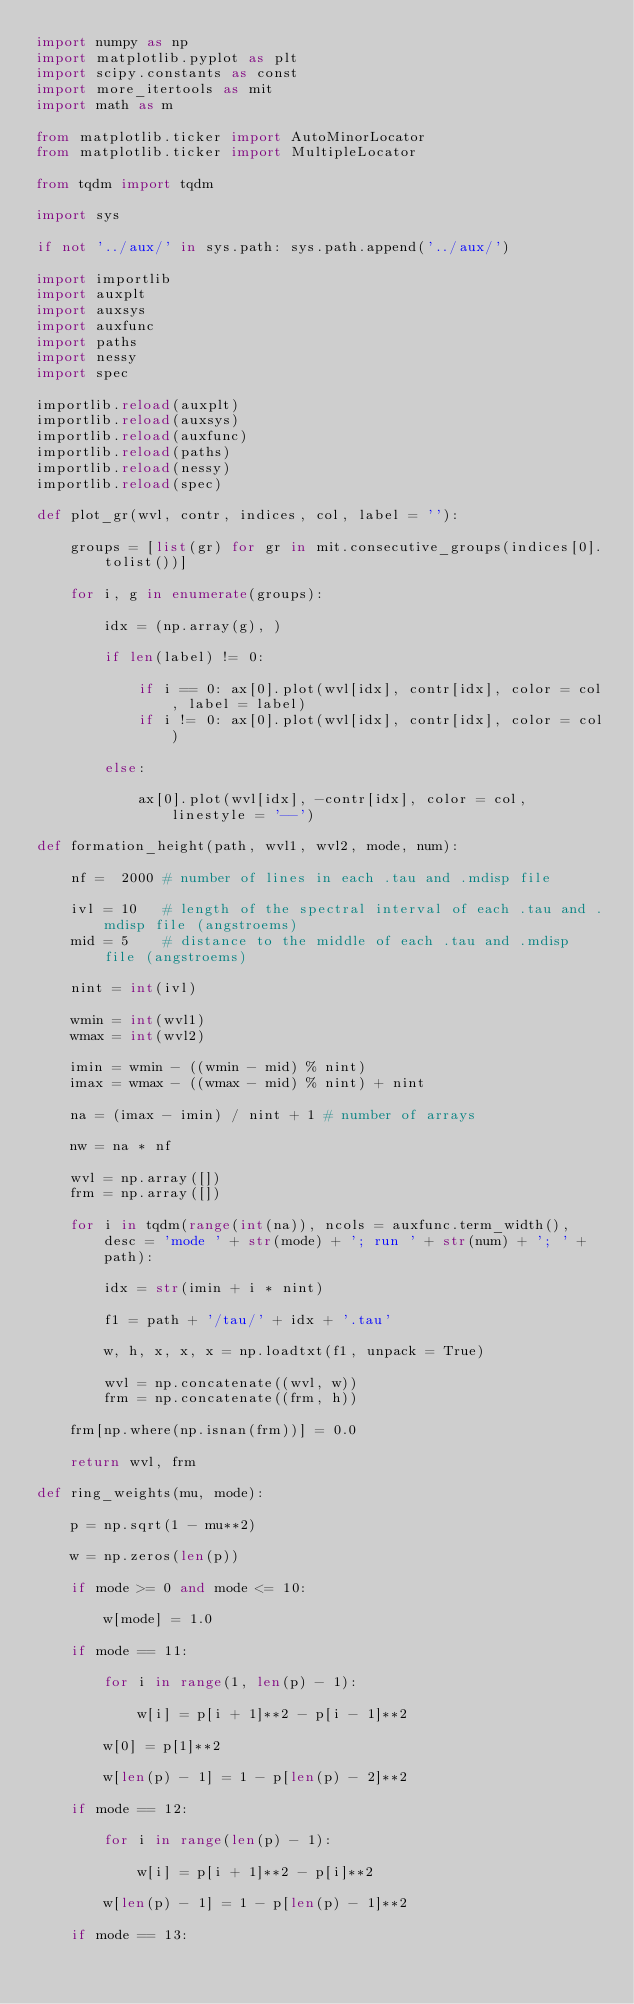Convert code to text. <code><loc_0><loc_0><loc_500><loc_500><_Python_>import numpy as np
import matplotlib.pyplot as plt
import scipy.constants as const
import more_itertools as mit
import math as m

from matplotlib.ticker import AutoMinorLocator
from matplotlib.ticker import MultipleLocator

from tqdm import tqdm

import sys

if not '../aux/' in sys.path: sys.path.append('../aux/')

import importlib
import auxplt
import auxsys
import auxfunc
import paths
import nessy
import spec

importlib.reload(auxplt)
importlib.reload(auxsys)
importlib.reload(auxfunc)
importlib.reload(paths)
importlib.reload(nessy)
importlib.reload(spec)

def plot_gr(wvl, contr, indices, col, label = ''):

    groups = [list(gr) for gr in mit.consecutive_groups(indices[0].tolist())]
    
    for i, g in enumerate(groups):

        idx = (np.array(g), )

        if len(label) != 0:

            if i == 0: ax[0].plot(wvl[idx], contr[idx], color = col, label = label)
            if i != 0: ax[0].plot(wvl[idx], contr[idx], color = col)

        else:

            ax[0].plot(wvl[idx], -contr[idx], color = col, linestyle = '--')

def formation_height(path, wvl1, wvl2, mode, num):

    nf =  2000 # number of lines in each .tau and .mdisp file

    ivl = 10   # length of the spectral interval of each .tau and .mdisp file (angstroems)
    mid = 5    # distance to the middle of each .tau and .mdisp file (angstroems)

    nint = int(ivl)

    wmin = int(wvl1)
    wmax = int(wvl2)

    imin = wmin - ((wmin - mid) % nint)
    imax = wmax - ((wmax - mid) % nint) + nint

    na = (imax - imin) / nint + 1 # number of arrays

    nw = na * nf

    wvl = np.array([])
    frm = np.array([])

    for i in tqdm(range(int(na)), ncols = auxfunc.term_width(), desc = 'mode ' + str(mode) + '; run ' + str(num) + '; ' + path):

        idx = str(imin + i * nint)

        f1 = path + '/tau/' + idx + '.tau'

        w, h, x, x, x = np.loadtxt(f1, unpack = True)

        wvl = np.concatenate((wvl, w))
        frm = np.concatenate((frm, h))

    frm[np.where(np.isnan(frm))] = 0.0

    return wvl, frm

def ring_weights(mu, mode):

    p = np.sqrt(1 - mu**2)

    w = np.zeros(len(p))

    if mode >= 0 and mode <= 10:

        w[mode] = 1.0

    if mode == 11:

        for i in range(1, len(p) - 1):

            w[i] = p[i + 1]**2 - p[i - 1]**2

        w[0] = p[1]**2

        w[len(p) - 1] = 1 - p[len(p) - 2]**2

    if mode == 12:

        for i in range(len(p) - 1):

            w[i] = p[i + 1]**2 - p[i]**2

        w[len(p) - 1] = 1 - p[len(p) - 1]**2

    if mode == 13:
</code> 